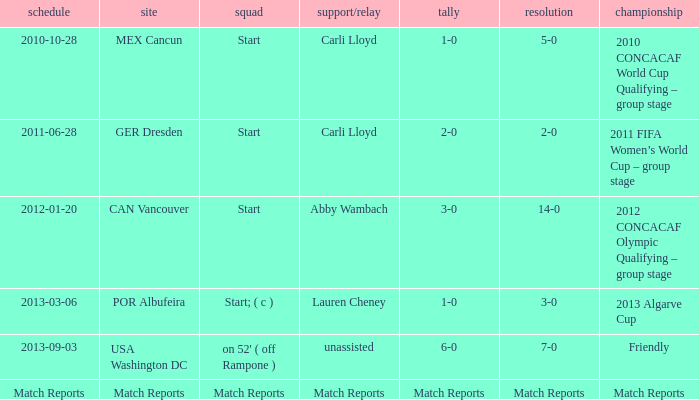Name the Result of the Lineup of start, an Assist/pass of carli lloyd, and an Competition of 2011 fifa women’s world cup – group stage? 2-0. 